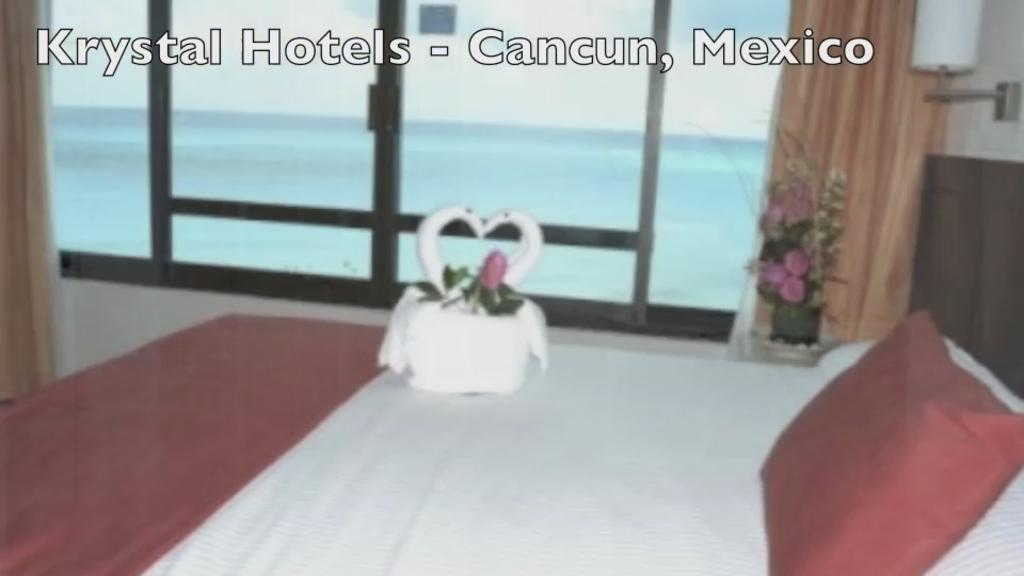What is on the bed in the image? There is a pillow and an object on the bed. What type of plant can be seen in the image? There is a houseplant in the image. What type of window treatment is present in the image? There are curtains in the image. What type of windows are visible in the image? There are glass windows in the image. Can you tell me how many clovers are growing in the image? There are no clovers present in the image. What type of operation is being performed in the image? There is no operation being performed in the image. 